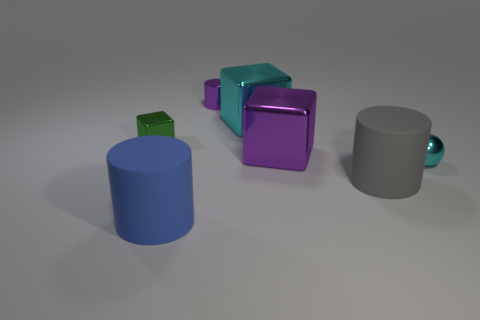Subtract all large cubes. How many cubes are left? 1 Add 1 tiny purple shiny objects. How many objects exist? 8 Subtract 1 cylinders. How many cylinders are left? 2 Subtract all big gray matte blocks. Subtract all cylinders. How many objects are left? 4 Add 4 green objects. How many green objects are left? 5 Add 2 large blue cylinders. How many large blue cylinders exist? 3 Subtract 1 green blocks. How many objects are left? 6 Subtract all spheres. How many objects are left? 6 Subtract all blue cylinders. Subtract all yellow blocks. How many cylinders are left? 2 Subtract all yellow cylinders. How many red cubes are left? 0 